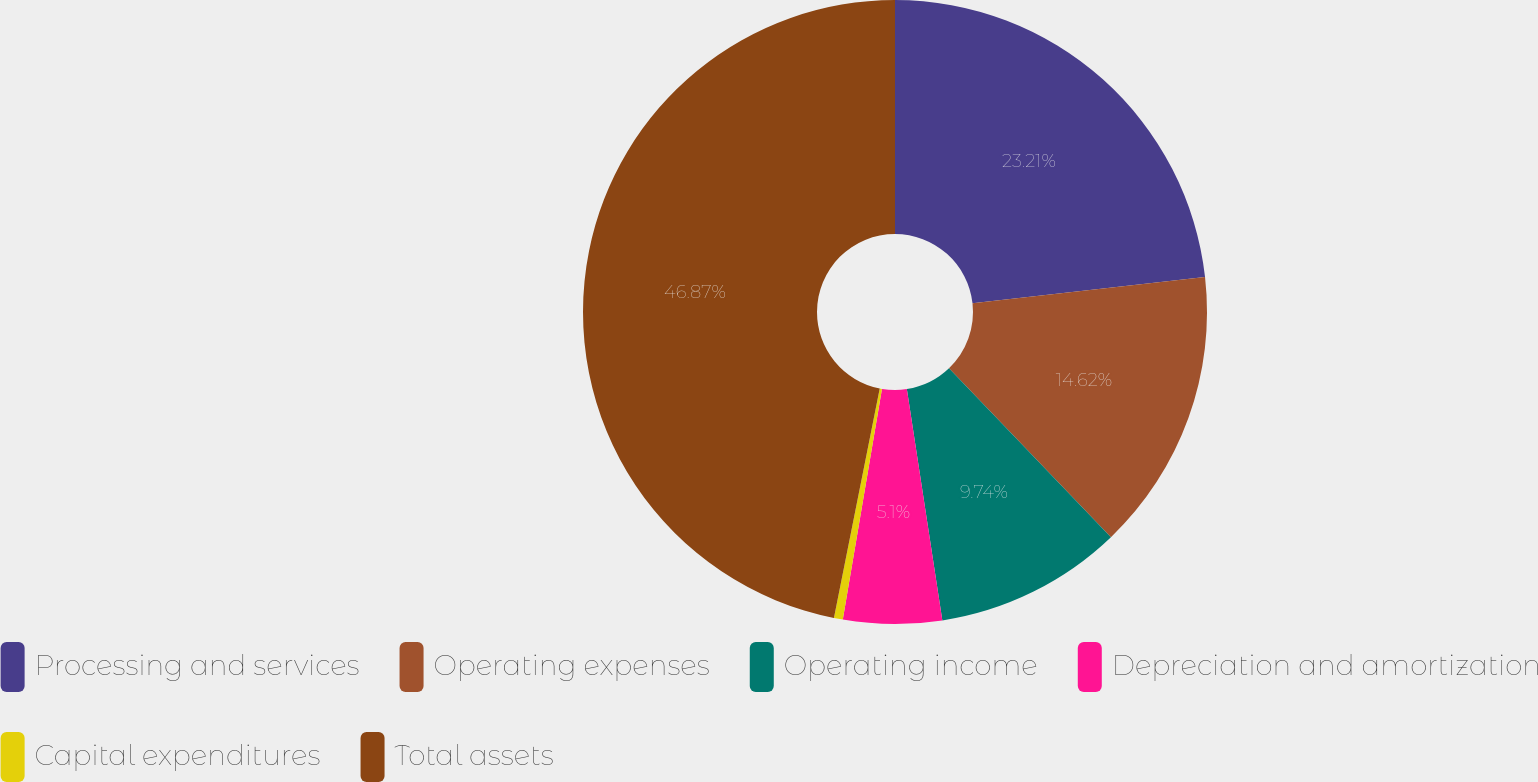<chart> <loc_0><loc_0><loc_500><loc_500><pie_chart><fcel>Processing and services<fcel>Operating expenses<fcel>Operating income<fcel>Depreciation and amortization<fcel>Capital expenditures<fcel>Total assets<nl><fcel>23.21%<fcel>14.62%<fcel>9.74%<fcel>5.1%<fcel>0.46%<fcel>46.86%<nl></chart> 